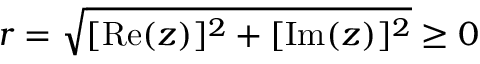<formula> <loc_0><loc_0><loc_500><loc_500>r = { \sqrt { [ R e ( z ) ] ^ { 2 } + [ I m ( z ) ] ^ { 2 } } } \geq 0</formula> 